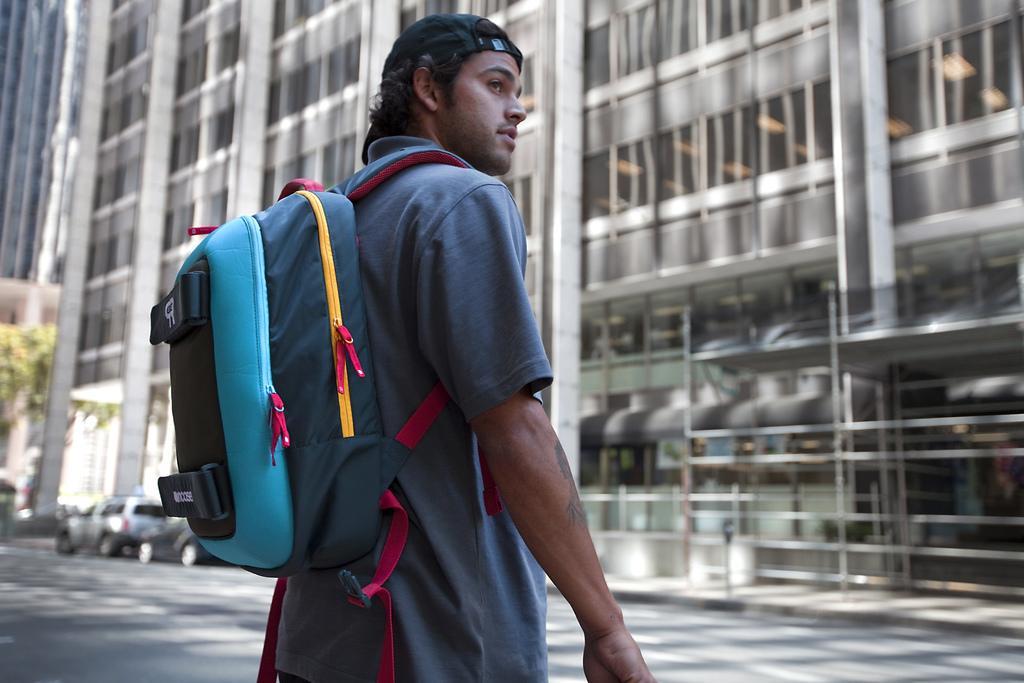In one or two sentences, can you explain what this image depicts? This is the picture outside of the city. He is standing. He's wearing a bag and his wearing a cap. We can see in the background there is a beautiful building,cars and trees. 